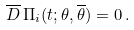<formula> <loc_0><loc_0><loc_500><loc_500>\overline { D } \, \Pi _ { i } ( t ; \theta , \overline { \theta } ) = 0 \, .</formula> 